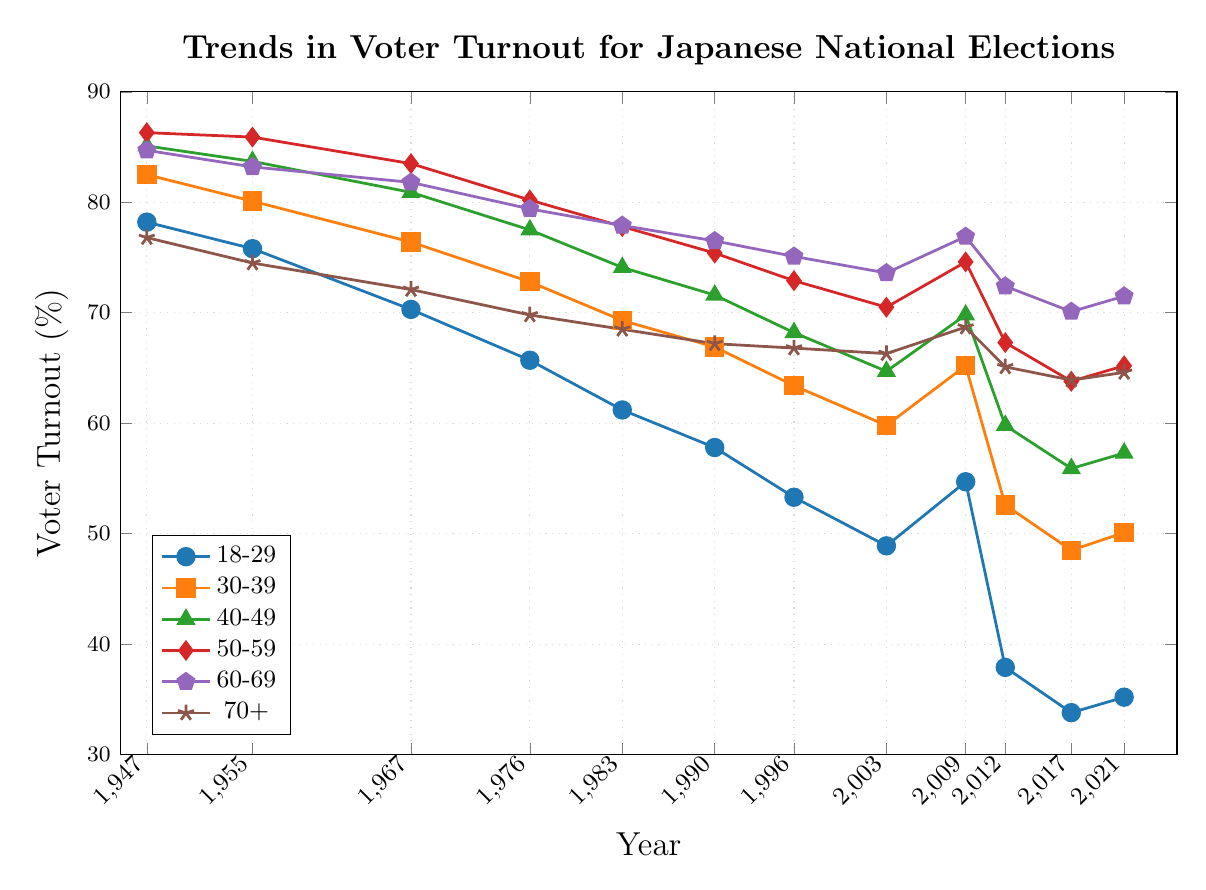What's the voter turnout for the age group 18-29 in 2021? To find the answer, look at the line associated with age group 18-29 and find the data point corresponding to the year 2021.
Answer: 35.2 Which age group had the highest voter turnout in 1967? Locate the data points for all age groups in 1967 and compare their values to find the highest one.
Answer: 50-59 How much did voter turnout for 70+ change from 1947 to 2021? Calculate the difference between the voter turnout in 1947 and 2021 for the age group 70+ by subtracting the 1947 value from the 2021 value.
Answer: -12.2 Which age group saw the largest decline in voter turnout from 1947 to 2021? Calculate the difference between the voter turnout in 1947 and 2021 for each age group and compare the declines to find the largest one.
Answer: 18-29 What is the average voter turnout for the age group 50-59 from 2009 to 2021? Find the voter turnout values for the age group 50-59 in 2009, 2012, 2017, and 2021, sum them up and divide by the number of years (4).
Answer: 67.725 Which two age groups had the closest voter turnout in 2017? Compare the voter turnout values of each age group in 2017 and determine which two are the closest to each other.
Answer: 60-69 and 70+ By how much did the voter turnout for the age group 30-39 drop from 1990 to 2012? Subtract the voter turnout of the age group 30-39 in 2012 from the value in 1990.
Answer: 14.3 What was the voter turnout trend for the age group 60-69 between 2009 and 2021? Observe the data points for the age group 60-69 from 2009 to 2021 to determine the trend.
Answer: Decreased Which age group had the most consistent voter turnout from 1947 to 2021? Check the voter turnout lines for all age groups from 1947 to 2021 and determine which one has the least fluctuation.
Answer: 70+ 